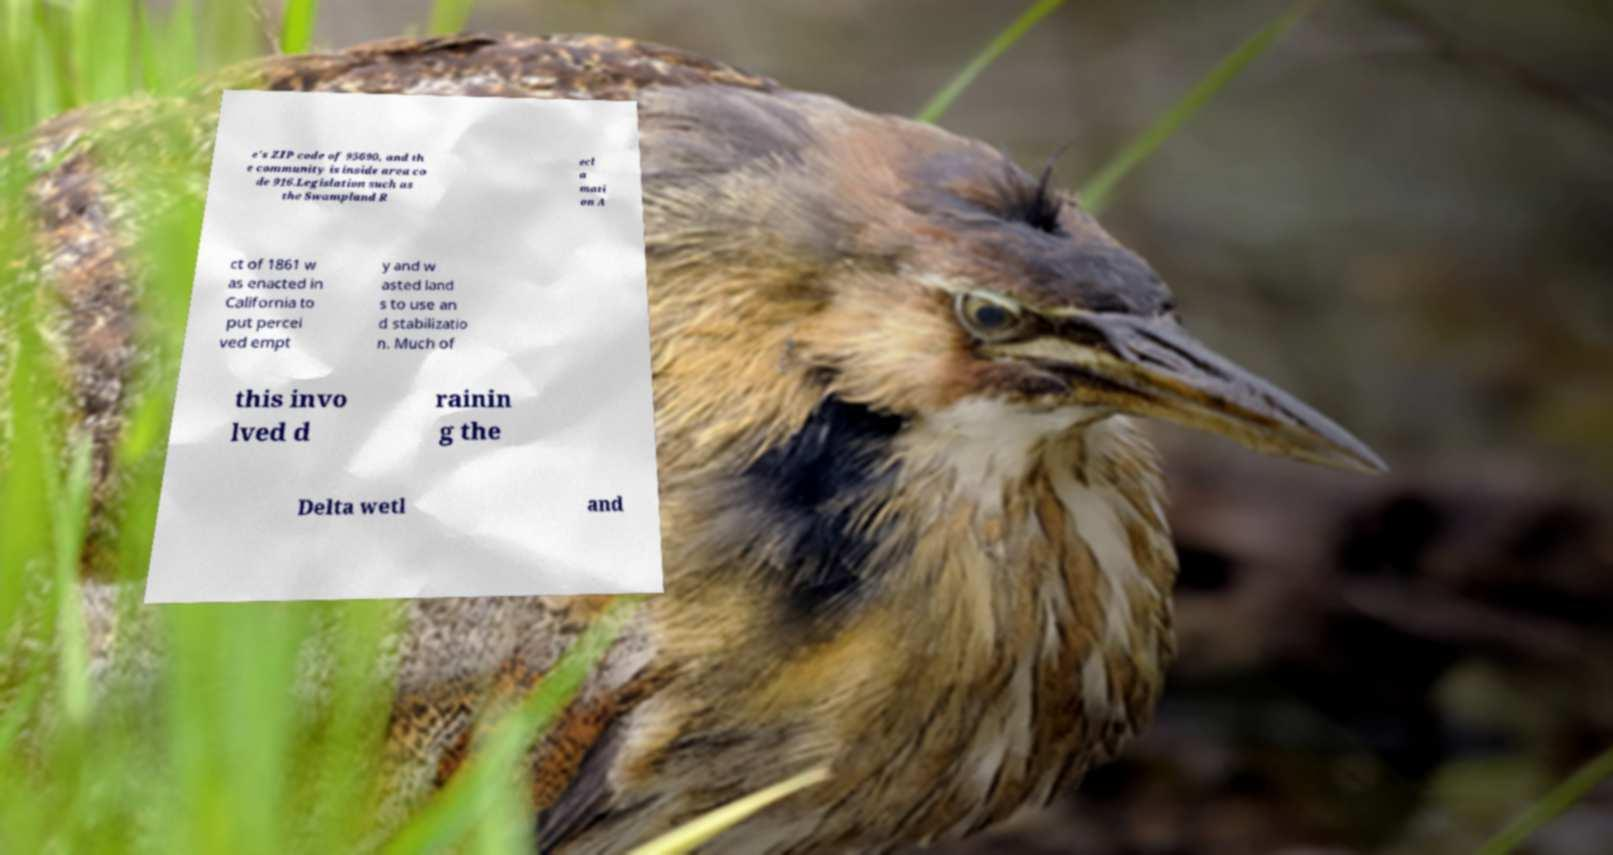Could you assist in decoding the text presented in this image and type it out clearly? e's ZIP code of 95690, and th e community is inside area co de 916.Legislation such as the Swampland R ecl a mati on A ct of 1861 w as enacted in California to put percei ved empt y and w asted land s to use an d stabilizatio n. Much of this invo lved d rainin g the Delta wetl and 